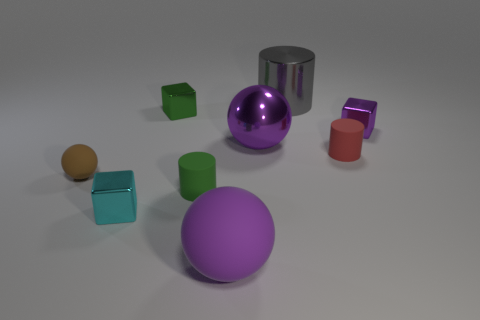Subtract all large metallic balls. How many balls are left? 2 Subtract all purple blocks. How many purple spheres are left? 2 Subtract 2 spheres. How many spheres are left? 1 Subtract all gray cylinders. How many cylinders are left? 2 Add 8 green cubes. How many green cubes are left? 9 Add 8 yellow matte cylinders. How many yellow matte cylinders exist? 8 Subtract 0 gray spheres. How many objects are left? 9 Subtract all blocks. How many objects are left? 6 Subtract all red balls. Subtract all purple cubes. How many balls are left? 3 Subtract all small green cylinders. Subtract all red cylinders. How many objects are left? 7 